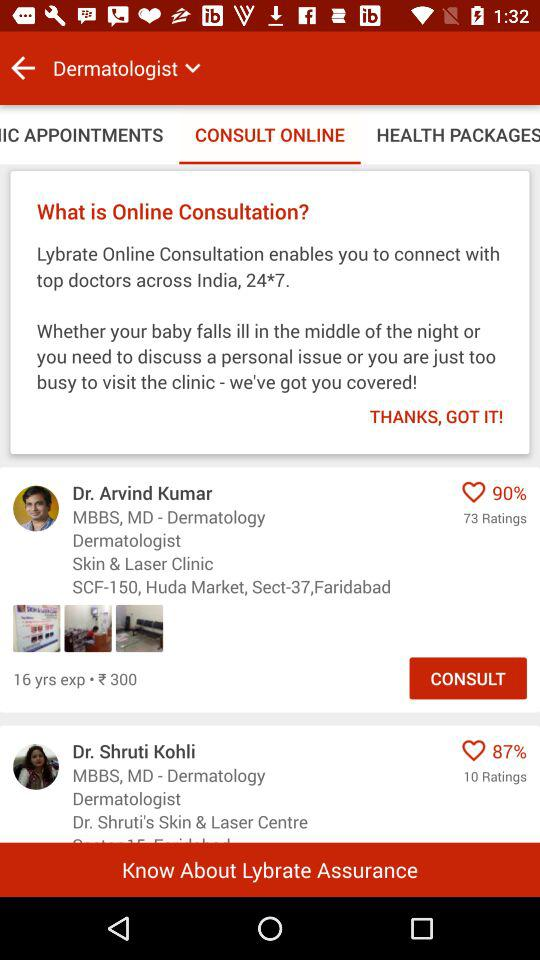What is the consultation fee for Dr. Arvind Kumar? The consultation fee for Dr. Arvind Kumar is 300 rupees. 